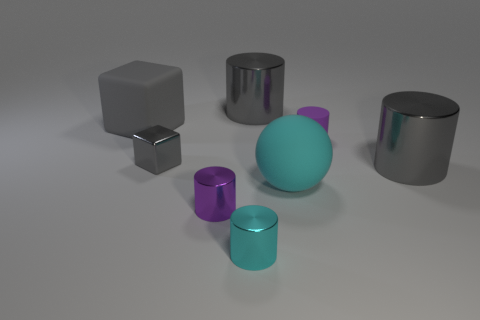What is the shape of the small matte object? The small matte object appears to be a cube. Its six faces are equally sized squares, giving it a distinct, regular symmetrical shape that is characteristic of a cube. 